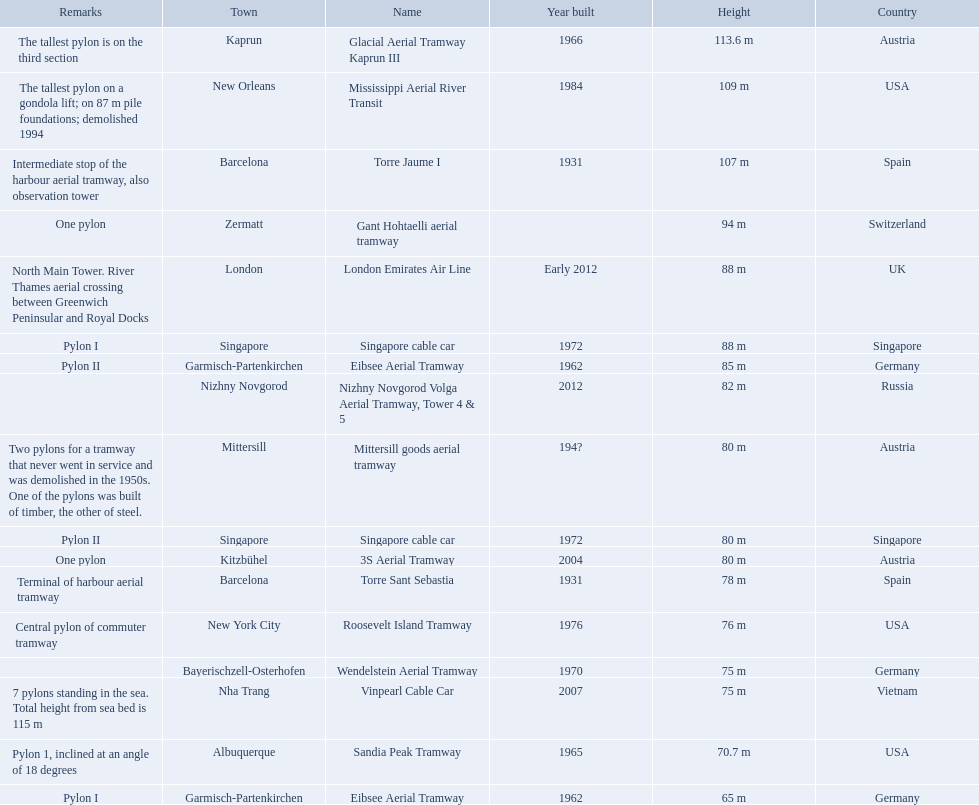Which aerial lifts are over 100 meters tall? Glacial Aerial Tramway Kaprun III, Mississippi Aerial River Transit, Torre Jaume I. Which of those was built last? Mississippi Aerial River Transit. And what is its total height? 109 m. 